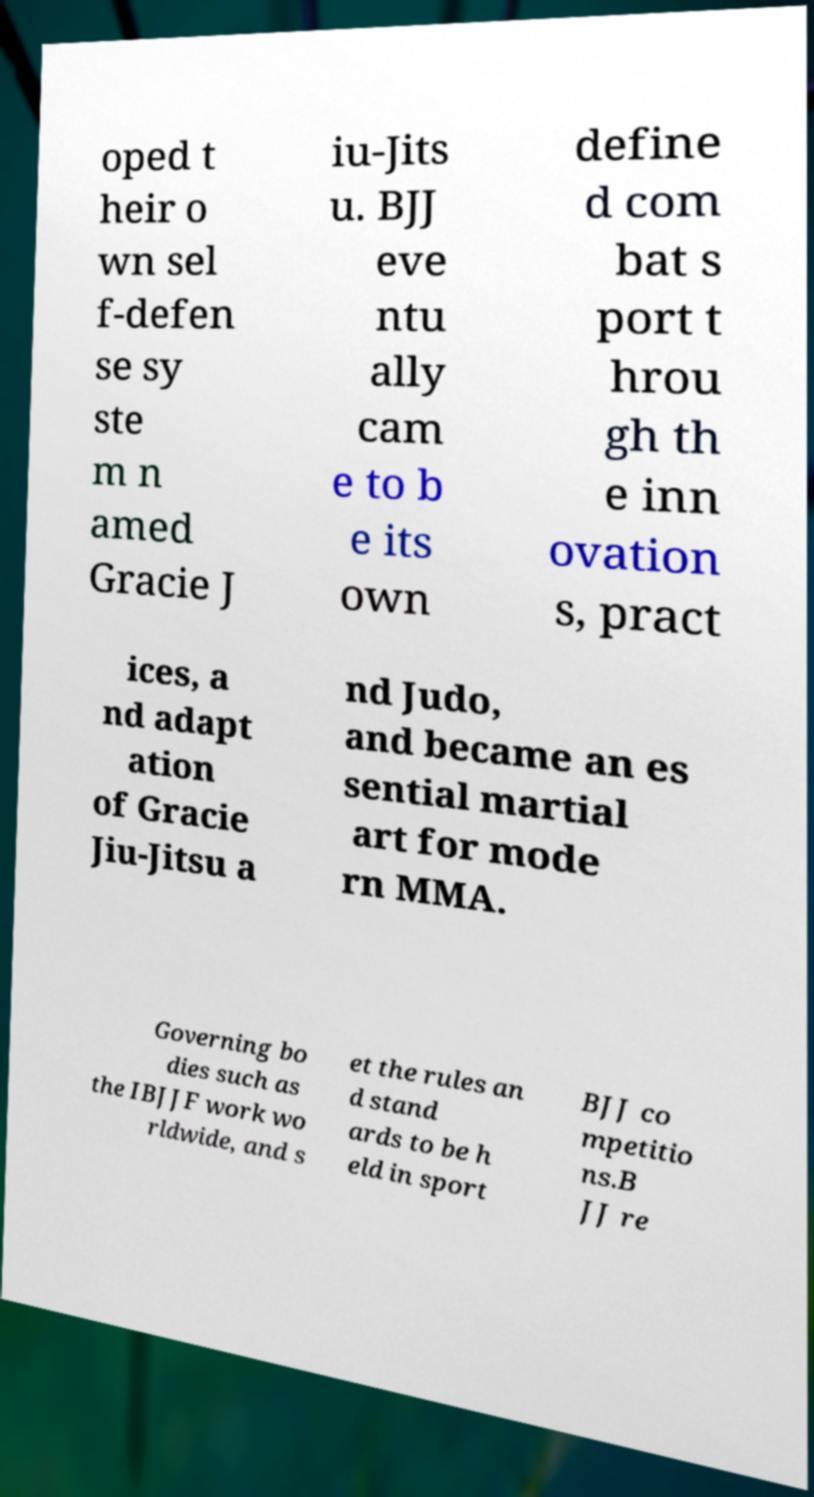Can you read and provide the text displayed in the image?This photo seems to have some interesting text. Can you extract and type it out for me? oped t heir o wn sel f-defen se sy ste m n amed Gracie J iu-Jits u. BJJ eve ntu ally cam e to b e its own define d com bat s port t hrou gh th e inn ovation s, pract ices, a nd adapt ation of Gracie Jiu-Jitsu a nd Judo, and became an es sential martial art for mode rn MMA. Governing bo dies such as the IBJJF work wo rldwide, and s et the rules an d stand ards to be h eld in sport BJJ co mpetitio ns.B JJ re 